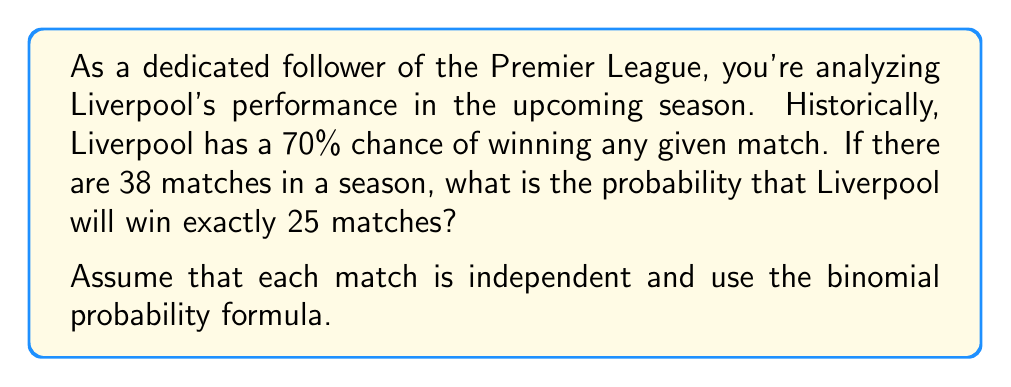Show me your answer to this math problem. Let's approach this step-by-step using the binomial probability formula:

1) We can model this scenario using a binomial distribution because:
   - There are a fixed number of trials (38 matches)
   - Each trial has two possible outcomes (win or not win)
   - The probability of success (winning) is constant for each trial
   - The trials are independent

2) The binomial probability formula is:

   $$P(X=k) = \binom{n}{k} p^k (1-p)^{n-k}$$

   Where:
   $n$ = number of trials
   $k$ = number of successes
   $p$ = probability of success on each trial

3) In this case:
   $n = 38$ (total matches in a season)
   $k = 25$ (exact number of wins we're interested in)
   $p = 0.70$ (probability of winning each match)

4) Let's substitute these values:

   $$P(X=25) = \binom{38}{25} (0.70)^{25} (1-0.70)^{38-25}$$

5) Simplify:
   $$P(X=25) = \binom{38}{25} (0.70)^{25} (0.30)^{13}$$

6) Calculate the binomial coefficient:
   $$\binom{38}{25} = \frac{38!}{25!(38-25)!} = \frac{38!}{25!13!} = 8,145,060,450$$

7) Now, let's compute the final probability:
   $$P(X=25) = 8,145,060,450 \times (0.70)^{25} \times (0.30)^{13} \approx 0.1152$$

8) Convert to percentage:
   $$0.1152 \times 100\% = 11.52\%$$
Answer: 11.52% 